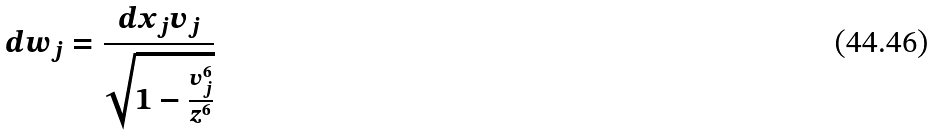Convert formula to latex. <formula><loc_0><loc_0><loc_500><loc_500>d w _ { j } = \frac { d x _ { j } v _ { j } } { \sqrt { 1 - \frac { v _ { j } ^ { 6 } } { z ^ { 6 } } } }</formula> 